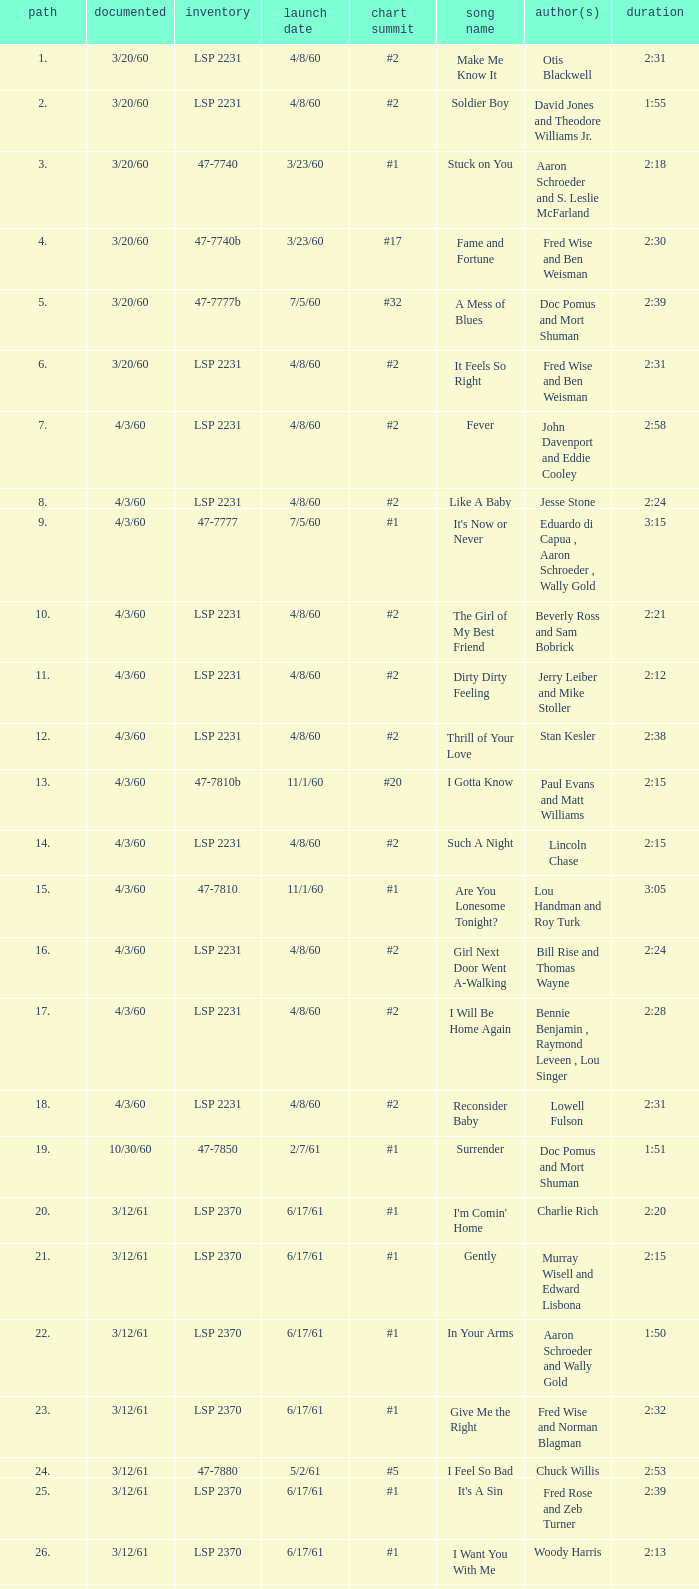On songs that have a release date of 6/17/61, a track larger than 20, and a writer of Woody Harris, what is the chart peak? #1. 